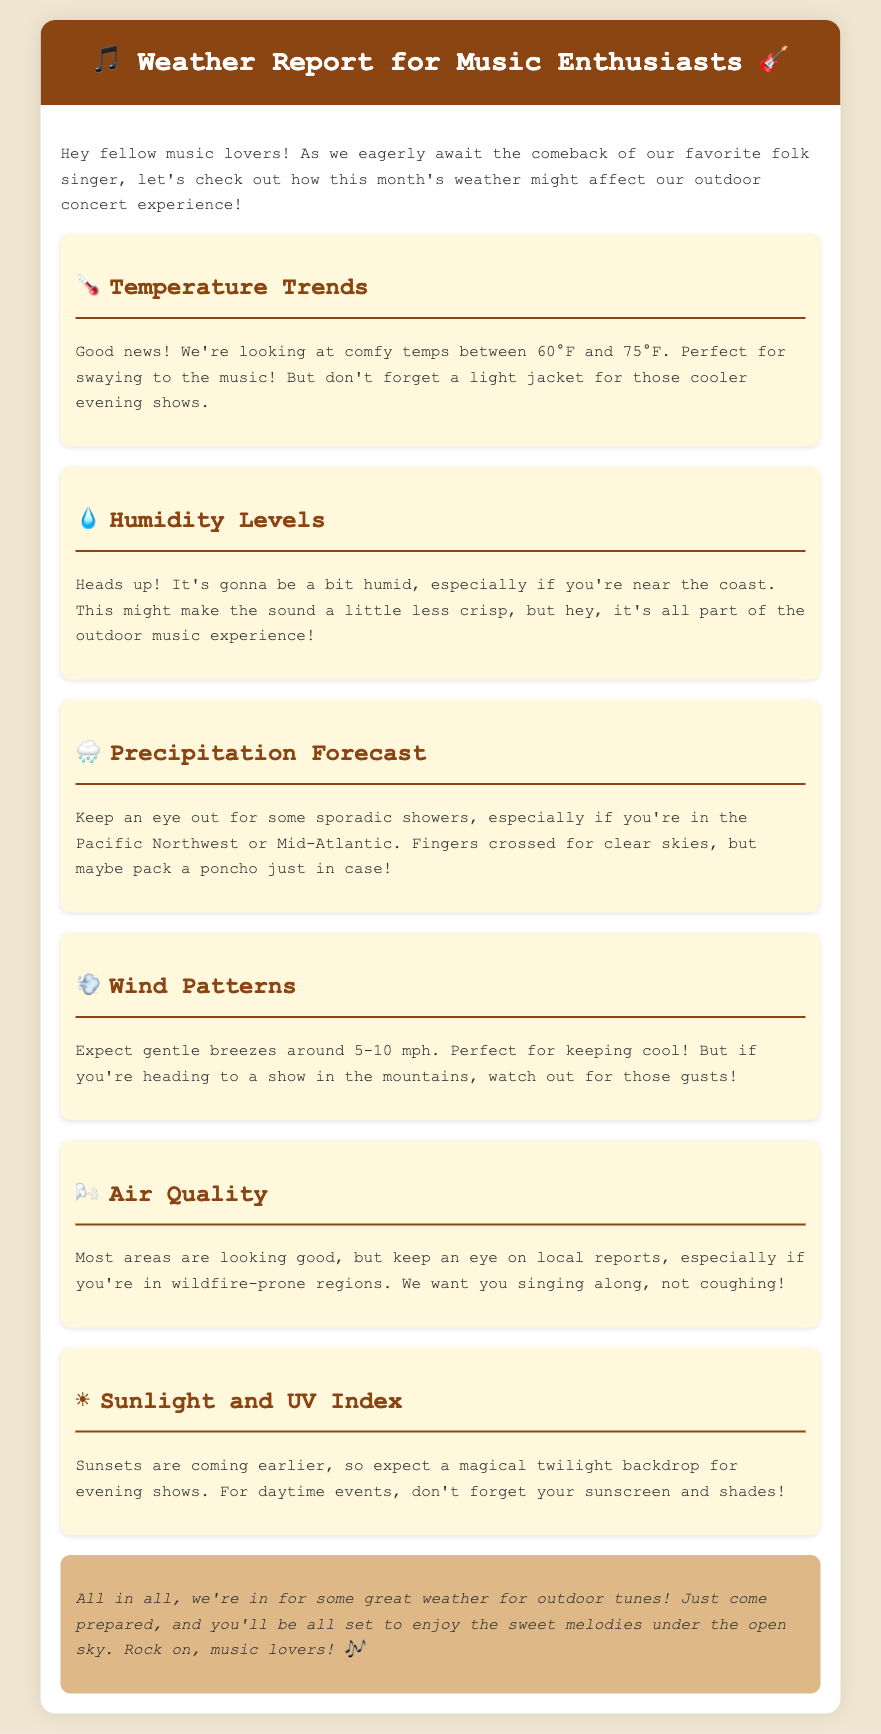What are the comfortable temperature ranges? The document states the comfortable temperatures are between 60°F and 75°F.
Answer: 60°F and 75°F What might affect the sound quality at outdoor concerts? The document mentions humid conditions might make the sound a little less crisp.
Answer: Humidity What should you pack for sporadic showers? The document suggests packing a poncho just in case of rain.
Answer: Poncho What is the expected wind speed? The document indicates gentle breezes around 5-10 mph.
Answer: 5-10 mph What is advised if you're in wildfire-prone regions? The document advises keeping an eye on local air quality reports.
Answer: Local reports What time of day will sunsets occur for evening shows? The document states that sunsets are coming earlier.
Answer: Earlier How does the document describe the overall weather for outdoor events? The document concludes that the weather is great for outdoor tunes.
Answer: Great What is recommended for daytime events under the sun? The document recommends using sunscreen and shades for daytime events.
Answer: Sunscreen and shades 